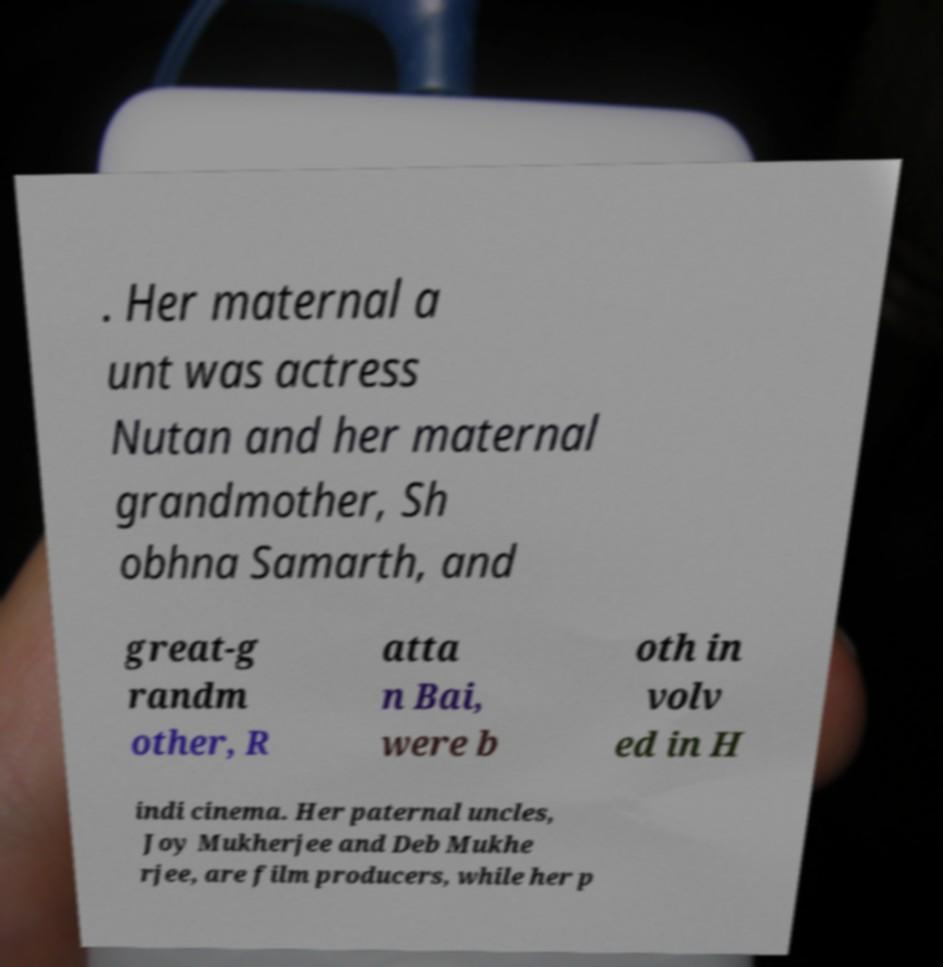Please identify and transcribe the text found in this image. . Her maternal a unt was actress Nutan and her maternal grandmother, Sh obhna Samarth, and great-g randm other, R atta n Bai, were b oth in volv ed in H indi cinema. Her paternal uncles, Joy Mukherjee and Deb Mukhe rjee, are film producers, while her p 